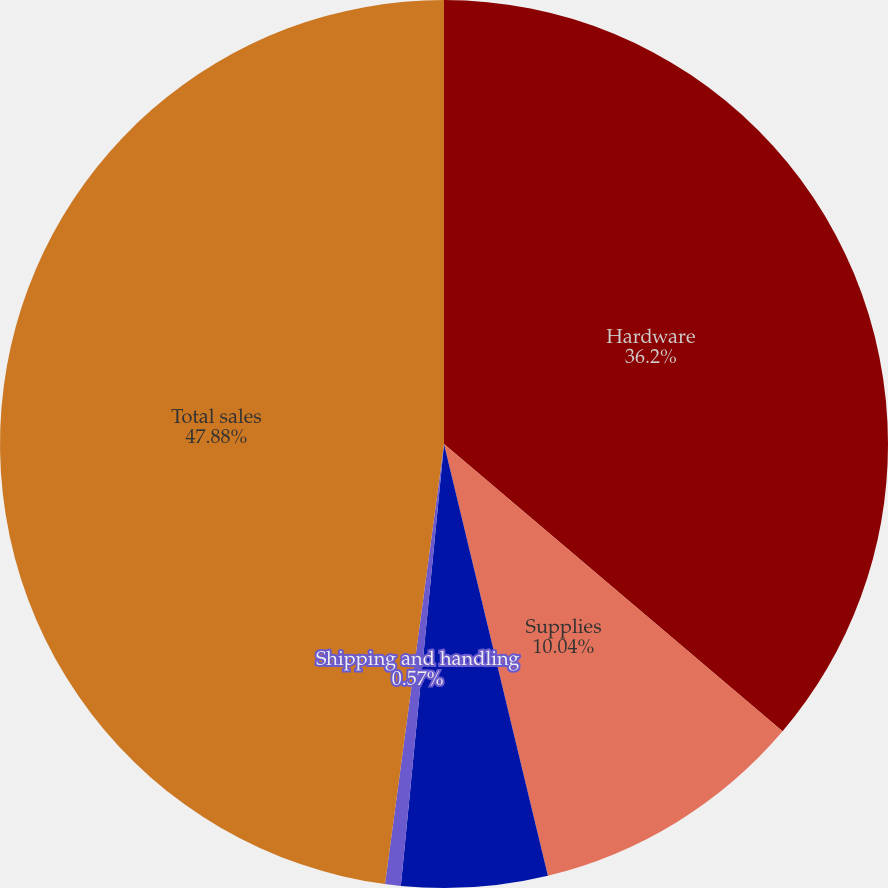<chart> <loc_0><loc_0><loc_500><loc_500><pie_chart><fcel>Hardware<fcel>Supplies<fcel>Service and software<fcel>Shipping and handling<fcel>Total sales<nl><fcel>36.2%<fcel>10.04%<fcel>5.31%<fcel>0.57%<fcel>47.88%<nl></chart> 